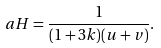<formula> <loc_0><loc_0><loc_500><loc_500>a H = \frac { 1 } { ( 1 + 3 k ) ( u + v ) } .</formula> 